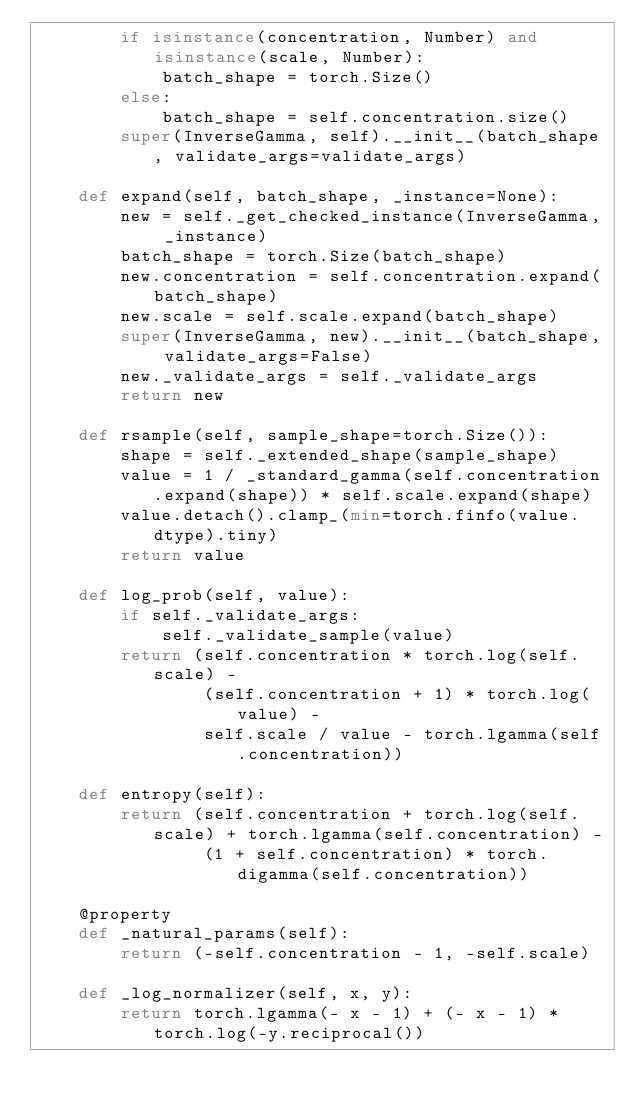Convert code to text. <code><loc_0><loc_0><loc_500><loc_500><_Python_>        if isinstance(concentration, Number) and isinstance(scale, Number):
            batch_shape = torch.Size()
        else:
            batch_shape = self.concentration.size()
        super(InverseGamma, self).__init__(batch_shape, validate_args=validate_args)

    def expand(self, batch_shape, _instance=None):
        new = self._get_checked_instance(InverseGamma, _instance)
        batch_shape = torch.Size(batch_shape)
        new.concentration = self.concentration.expand(batch_shape)
        new.scale = self.scale.expand(batch_shape)
        super(InverseGamma, new).__init__(batch_shape, validate_args=False)
        new._validate_args = self._validate_args
        return new

    def rsample(self, sample_shape=torch.Size()):
        shape = self._extended_shape(sample_shape)
        value = 1 / _standard_gamma(self.concentration.expand(shape)) * self.scale.expand(shape)
        value.detach().clamp_(min=torch.finfo(value.dtype).tiny)
        return value

    def log_prob(self, value):
        if self._validate_args:
            self._validate_sample(value)
        return (self.concentration * torch.log(self.scale) -
                (self.concentration + 1) * torch.log(value) -
                self.scale / value - torch.lgamma(self.concentration))

    def entropy(self):
        return (self.concentration + torch.log(self.scale) + torch.lgamma(self.concentration) -
                (1 + self.concentration) * torch.digamma(self.concentration))

    @property
    def _natural_params(self):
        return (-self.concentration - 1, -self.scale)

    def _log_normalizer(self, x, y):
        return torch.lgamma(- x - 1) + (- x - 1) * torch.log(-y.reciprocal())
</code> 